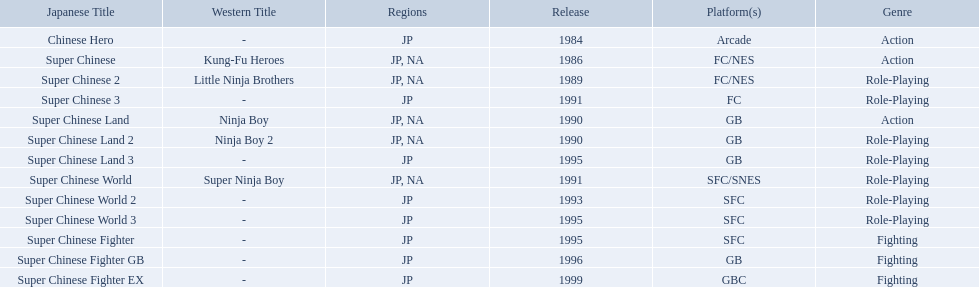Super ninja world was released in what countries? JP, NA. What was the original name for this title? Super Chinese World. Which titles were released in north america? Super Chinese, Super Chinese 2, Super Chinese Land, Super Chinese Land 2, Super Chinese World. Of those, which had the least releases? Super Chinese World. What japanese titles were released in the north american (na) region? Super Chinese, Super Chinese 2, Super Chinese Land, Super Chinese Land 2, Super Chinese World. Of those, which one was released most recently? Super Chinese World. What japanese titles were made available in the north american (na) region? Super Chinese, Super Chinese 2, Super Chinese Land, Super Chinese Land 2, Super Chinese World. Of those, which one was distributed most recently? Super Chinese World. Which titles were made available in north america? Super Chinese, Super Chinese 2, Super Chinese Land, Super Chinese Land 2, Super Chinese World. From those, which had the least amount of releases? Super Chinese World. In which nations was super ninja world launched? JP, NA. What was the initial name for this title? Super Chinese World. 